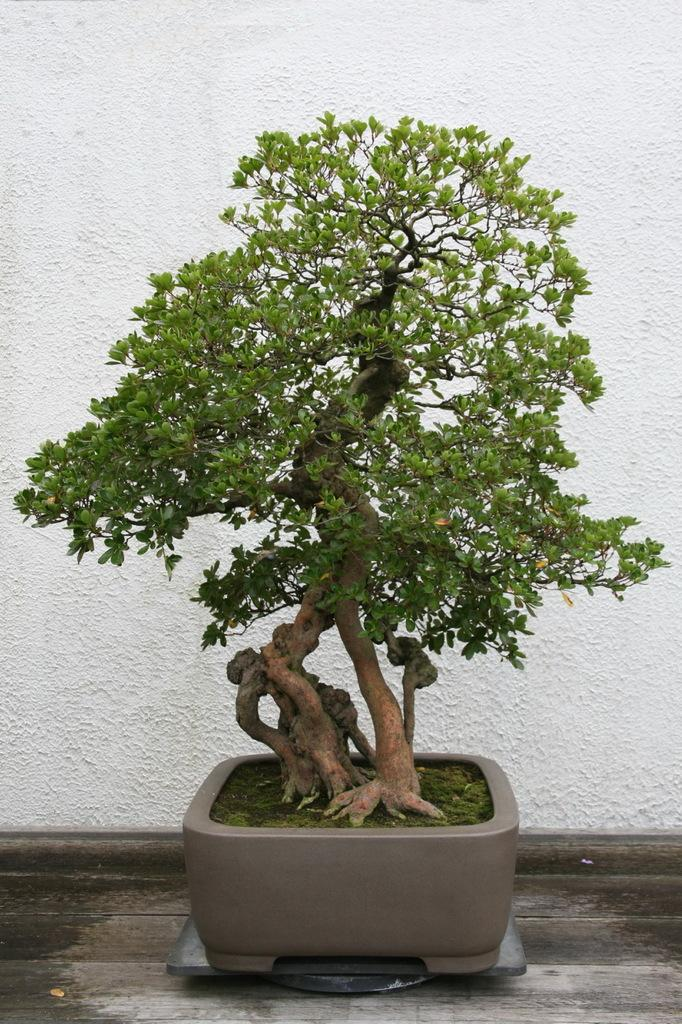What is the main object in the image? There is a plant in a pot in the image. Where is the plant located in the image? The plant is located in the middle of the image. What can be seen in the background of the image? There is a wall in the background of the image. What type of furniture is being selected in the image? There is no furniture present in the image; it features a plant in a pot and a wall in the background. 